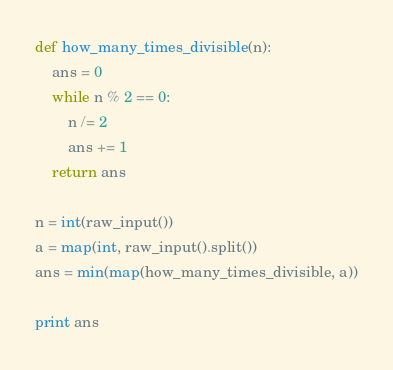Convert code to text. <code><loc_0><loc_0><loc_500><loc_500><_Python_>def how_many_times_divisible(n):
	ans = 0
	while n % 2 == 0:
		n /= 2
		ans += 1
	return ans
 
n = int(raw_input())
a = map(int, raw_input().split())
ans = min(map(how_many_times_divisible, a))
 
print ans</code> 